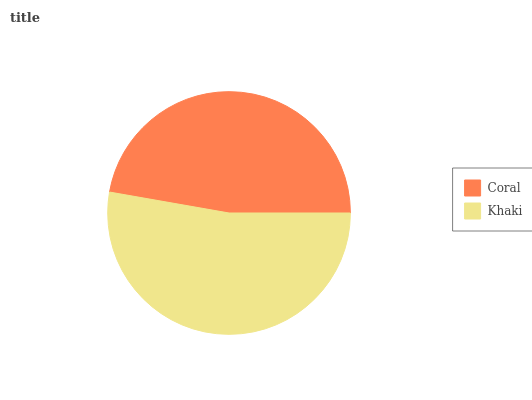Is Coral the minimum?
Answer yes or no. Yes. Is Khaki the maximum?
Answer yes or no. Yes. Is Khaki the minimum?
Answer yes or no. No. Is Khaki greater than Coral?
Answer yes or no. Yes. Is Coral less than Khaki?
Answer yes or no. Yes. Is Coral greater than Khaki?
Answer yes or no. No. Is Khaki less than Coral?
Answer yes or no. No. Is Khaki the high median?
Answer yes or no. Yes. Is Coral the low median?
Answer yes or no. Yes. Is Coral the high median?
Answer yes or no. No. Is Khaki the low median?
Answer yes or no. No. 